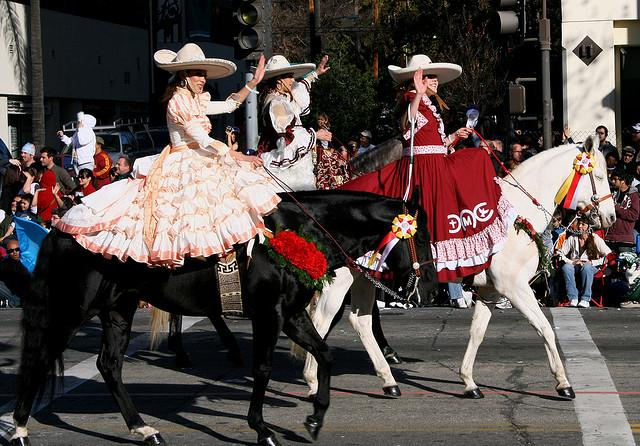What color is the woman's dress who is riding a white stallion? red 